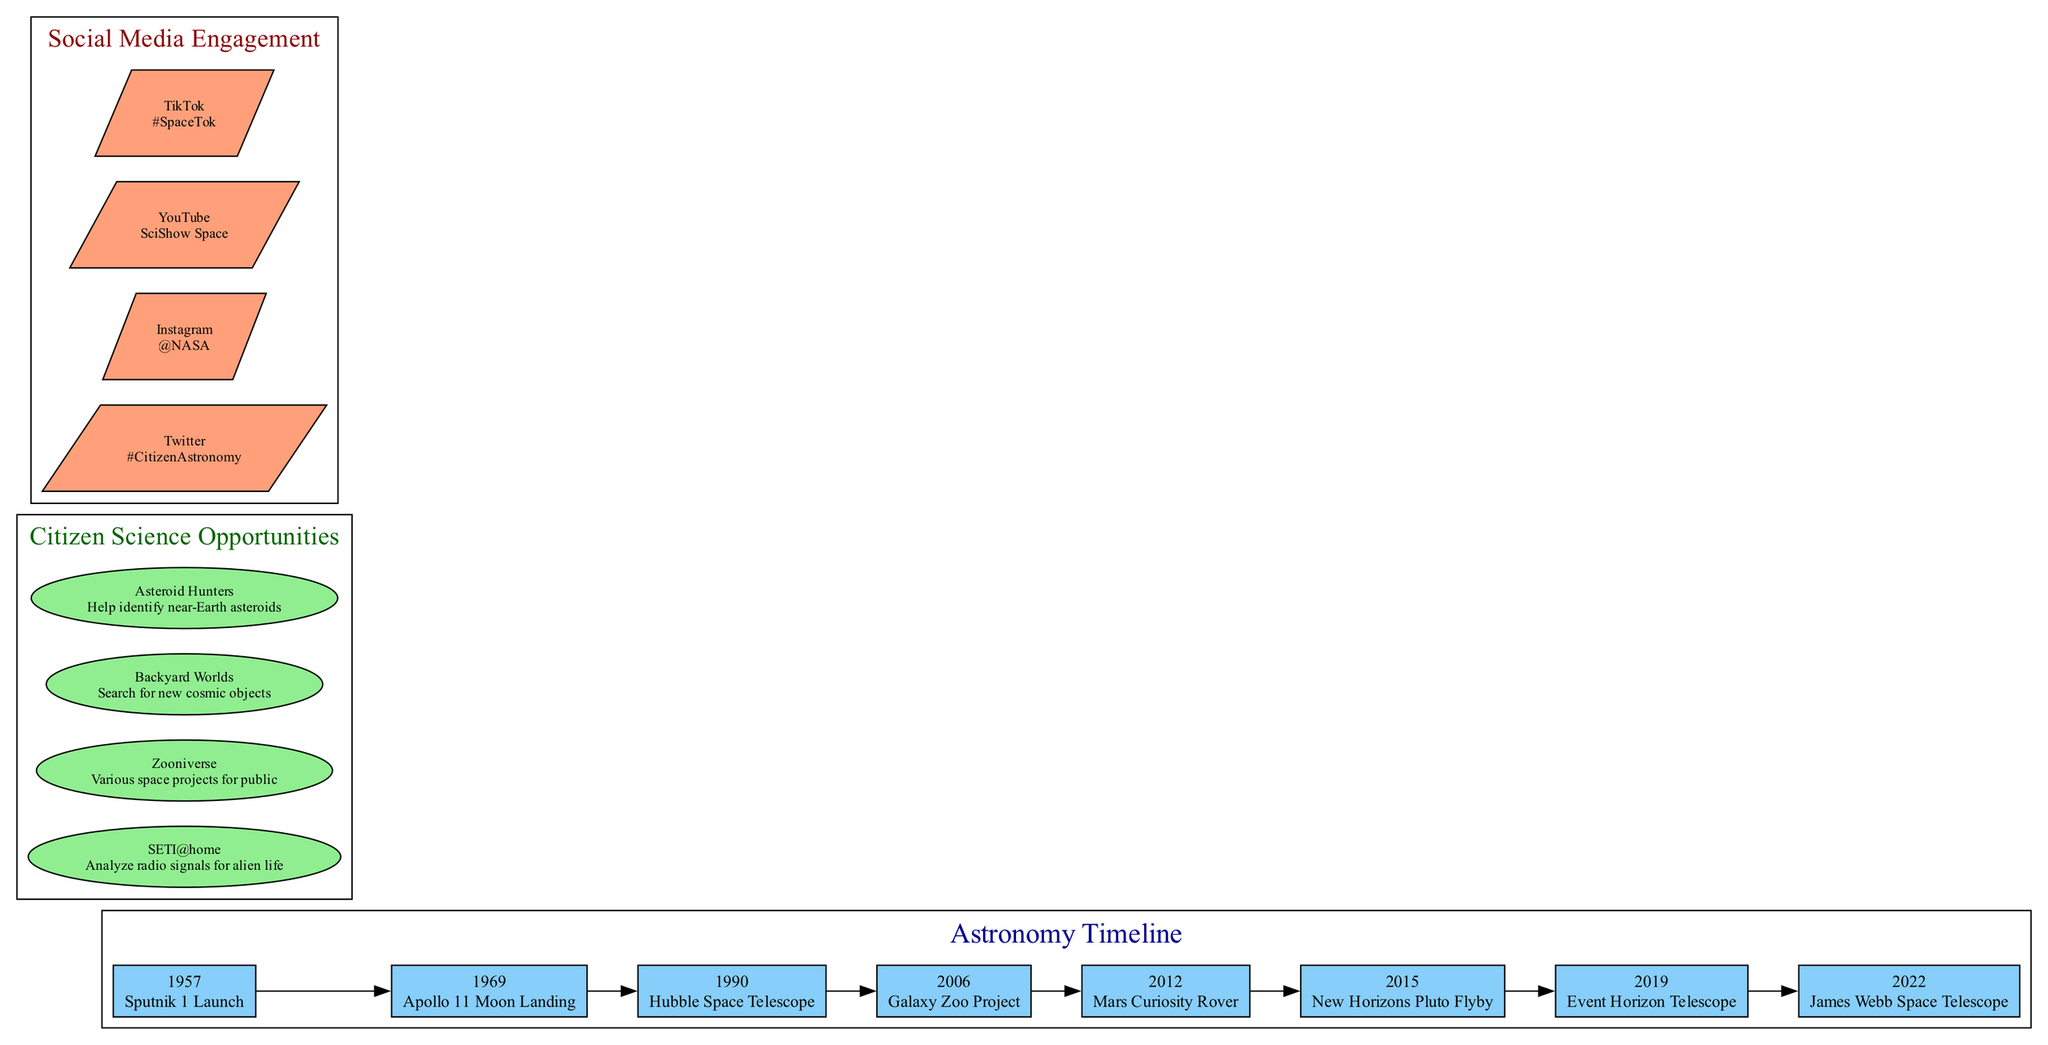What year did the Hubble Space Telescope launch? The diagram lists the event "Hubble Space Telescope" under the year 1990 in the timeline section, indicating its launch year.
Answer: 1990 What is the event associated with the year 1969? The timeline clearly shows that the year 1969 corresponds to the event "Apollo 11 Moon Landing", thus providing a direct match.
Answer: Apollo 11 Moon Landing How many major space events are shown in the timeline? By counting the number of events listed in the timeline, we find there are eight distinct space events included, representing significant milestones.
Answer: 8 Which citizen science opportunity focuses on identifying near-Earth asteroids? The "Asteroid Hunters" opportunity is specifically highlighted in the citizen science opportunities section as it relates to identifying near-Earth asteroids.
Answer: Asteroid Hunters What year follows the event "Galaxy Zoo Project" in the timeline? By examining the order of events in the timeline, we see that the "Galaxy Zoo Project" in 2006 is followed by the event in 2012, which is the "Mars Curiosity Rover".
Answer: 2012 What is the purpose of the SETI@home project? The diagram states that SETI@home is about analyzing radio signals for alien life, which succinctly describes its primary goal.
Answer: Analyze radio signals for alien life Which social media platform features the hashtag #SpaceTok? The diagram lists TikTok as the social media platform associated with the hashtag #SpaceTok, giving a direct answer to the inquiry.
Answer: TikTok Identify the first event in the timeline. By looking at the chronological order of events in the timeline, it is clear that the first event listed is the "Sputnik 1 Launch" occurring in 1957.
Answer: Sputnik 1 Launch What is the focus of the Galaxy Zoo Project? The description linked to the Galaxy Zoo Project emphasizes that it involves citizen science in classifying galaxies, thus outlining its main focus.
Answer: Classifying galaxies 